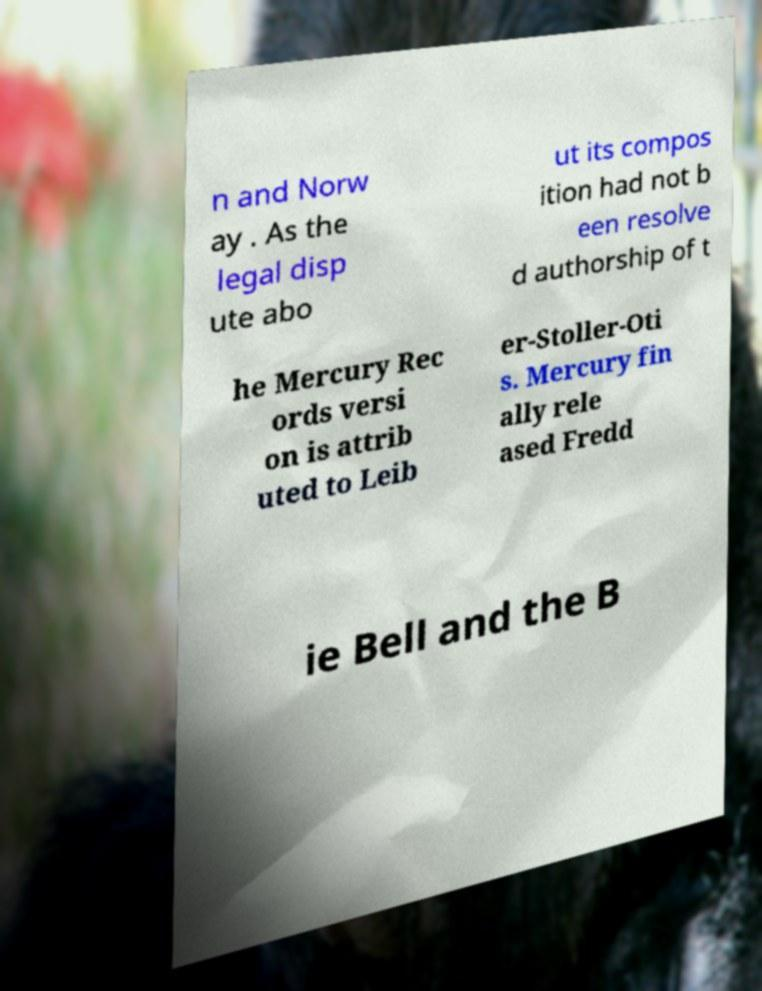I need the written content from this picture converted into text. Can you do that? n and Norw ay . As the legal disp ute abo ut its compos ition had not b een resolve d authorship of t he Mercury Rec ords versi on is attrib uted to Leib er-Stoller-Oti s. Mercury fin ally rele ased Fredd ie Bell and the B 